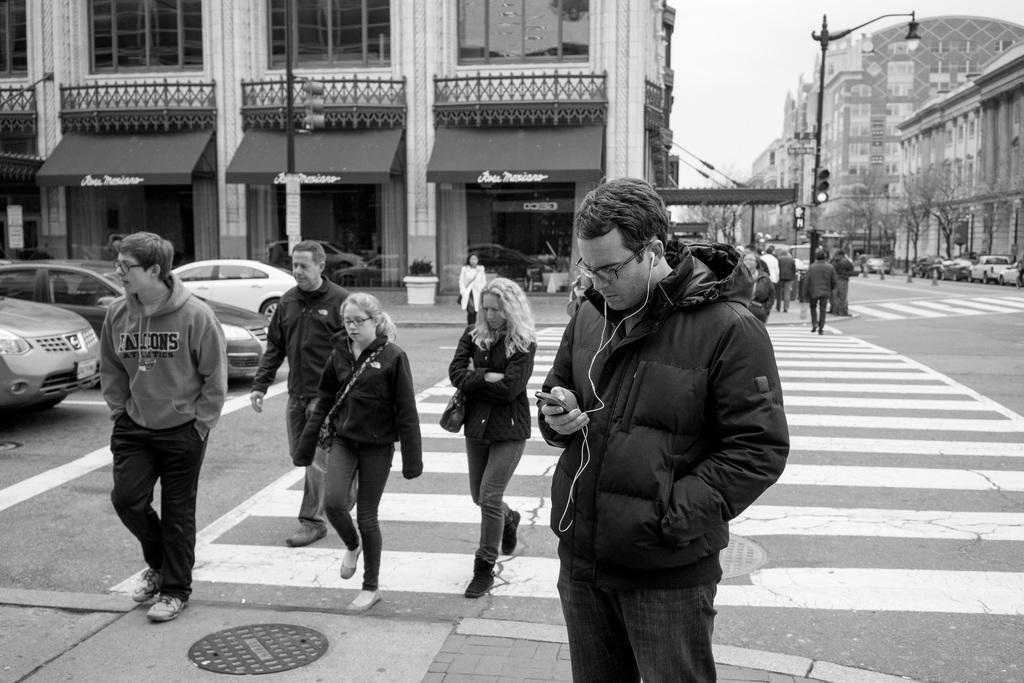Describe this image in one or two sentences. In this picture we can see some persons are walking on the road, beside there are few vehicles and some buildings. 